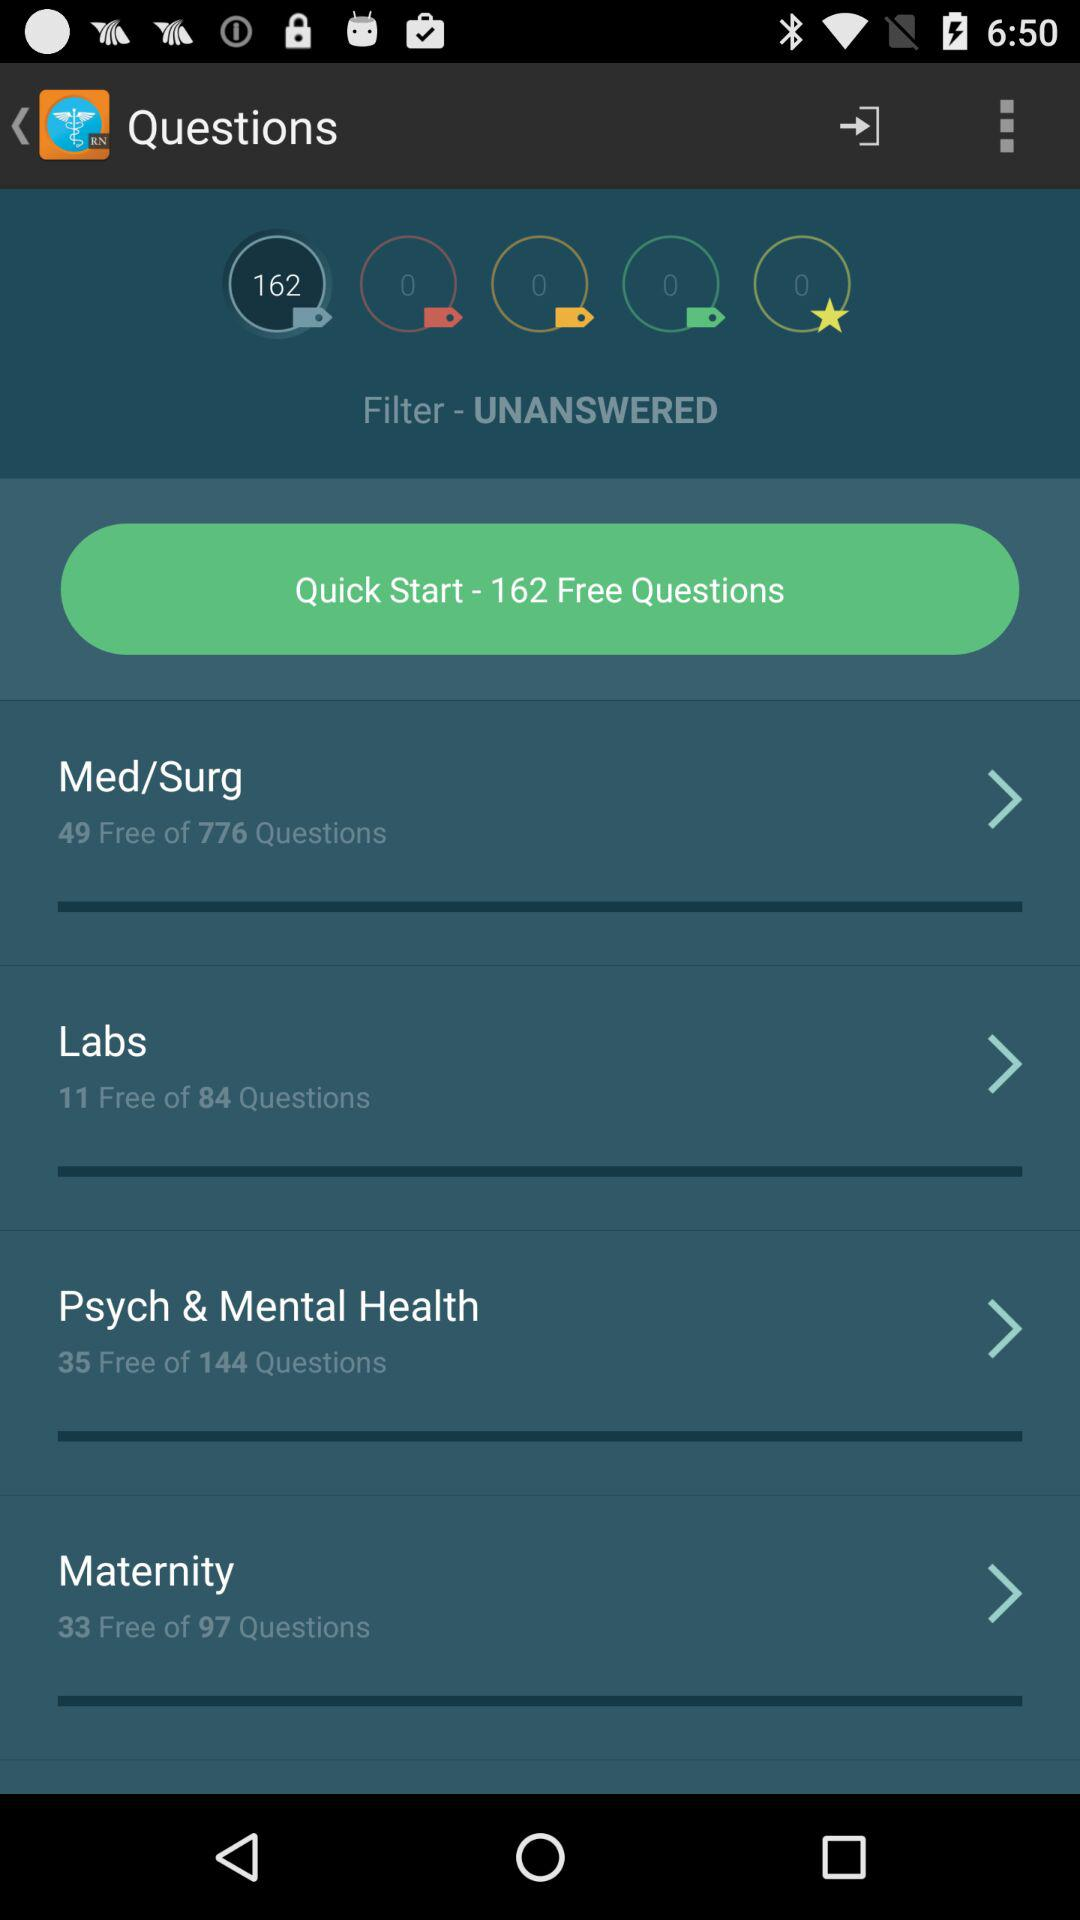What is the number of free questions in "Labs"? The number of free questions in "Labs" is 11. 